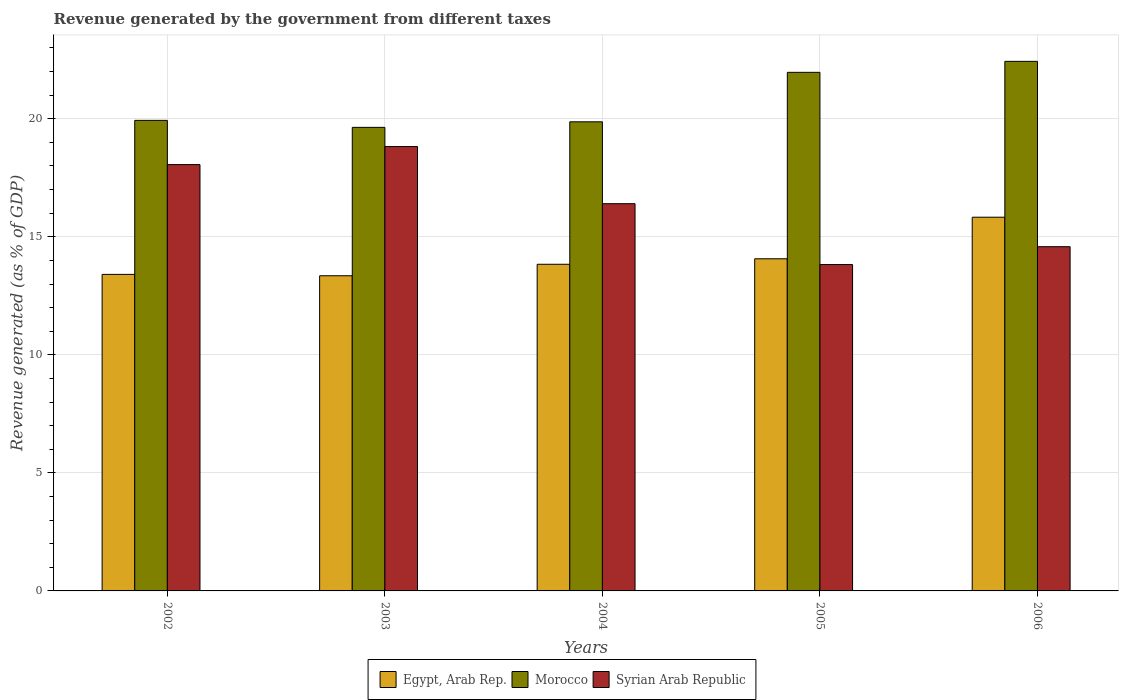How many different coloured bars are there?
Offer a very short reply. 3. How many bars are there on the 1st tick from the left?
Your answer should be very brief. 3. What is the label of the 2nd group of bars from the left?
Offer a terse response. 2003. In how many cases, is the number of bars for a given year not equal to the number of legend labels?
Your response must be concise. 0. What is the revenue generated by the government in Morocco in 2003?
Your answer should be compact. 19.64. Across all years, what is the maximum revenue generated by the government in Egypt, Arab Rep.?
Offer a terse response. 15.83. Across all years, what is the minimum revenue generated by the government in Egypt, Arab Rep.?
Keep it short and to the point. 13.35. In which year was the revenue generated by the government in Egypt, Arab Rep. maximum?
Your response must be concise. 2006. What is the total revenue generated by the government in Egypt, Arab Rep. in the graph?
Provide a short and direct response. 70.49. What is the difference between the revenue generated by the government in Egypt, Arab Rep. in 2005 and that in 2006?
Your answer should be very brief. -1.76. What is the difference between the revenue generated by the government in Morocco in 2005 and the revenue generated by the government in Syrian Arab Republic in 2004?
Provide a short and direct response. 5.56. What is the average revenue generated by the government in Egypt, Arab Rep. per year?
Offer a very short reply. 14.1. In the year 2002, what is the difference between the revenue generated by the government in Egypt, Arab Rep. and revenue generated by the government in Morocco?
Your answer should be compact. -6.52. What is the ratio of the revenue generated by the government in Egypt, Arab Rep. in 2002 to that in 2004?
Your response must be concise. 0.97. Is the revenue generated by the government in Morocco in 2004 less than that in 2005?
Your answer should be compact. Yes. Is the difference between the revenue generated by the government in Egypt, Arab Rep. in 2004 and 2005 greater than the difference between the revenue generated by the government in Morocco in 2004 and 2005?
Make the answer very short. Yes. What is the difference between the highest and the second highest revenue generated by the government in Morocco?
Keep it short and to the point. 0.47. What is the difference between the highest and the lowest revenue generated by the government in Egypt, Arab Rep.?
Ensure brevity in your answer.  2.48. In how many years, is the revenue generated by the government in Morocco greater than the average revenue generated by the government in Morocco taken over all years?
Offer a terse response. 2. What does the 1st bar from the left in 2003 represents?
Provide a short and direct response. Egypt, Arab Rep. What does the 1st bar from the right in 2005 represents?
Offer a terse response. Syrian Arab Republic. Is it the case that in every year, the sum of the revenue generated by the government in Morocco and revenue generated by the government in Egypt, Arab Rep. is greater than the revenue generated by the government in Syrian Arab Republic?
Offer a very short reply. Yes. How many bars are there?
Offer a terse response. 15. Are all the bars in the graph horizontal?
Your answer should be compact. No. Are the values on the major ticks of Y-axis written in scientific E-notation?
Make the answer very short. No. Does the graph contain grids?
Offer a very short reply. Yes. Where does the legend appear in the graph?
Your response must be concise. Bottom center. What is the title of the graph?
Your answer should be very brief. Revenue generated by the government from different taxes. What is the label or title of the Y-axis?
Ensure brevity in your answer.  Revenue generated (as % of GDP). What is the Revenue generated (as % of GDP) in Egypt, Arab Rep. in 2002?
Make the answer very short. 13.41. What is the Revenue generated (as % of GDP) of Morocco in 2002?
Offer a terse response. 19.93. What is the Revenue generated (as % of GDP) in Syrian Arab Republic in 2002?
Keep it short and to the point. 18.06. What is the Revenue generated (as % of GDP) of Egypt, Arab Rep. in 2003?
Provide a short and direct response. 13.35. What is the Revenue generated (as % of GDP) in Morocco in 2003?
Your answer should be very brief. 19.64. What is the Revenue generated (as % of GDP) in Syrian Arab Republic in 2003?
Ensure brevity in your answer.  18.82. What is the Revenue generated (as % of GDP) of Egypt, Arab Rep. in 2004?
Keep it short and to the point. 13.84. What is the Revenue generated (as % of GDP) in Morocco in 2004?
Keep it short and to the point. 19.87. What is the Revenue generated (as % of GDP) in Syrian Arab Republic in 2004?
Give a very brief answer. 16.4. What is the Revenue generated (as % of GDP) of Egypt, Arab Rep. in 2005?
Your answer should be very brief. 14.07. What is the Revenue generated (as % of GDP) in Morocco in 2005?
Your answer should be very brief. 21.97. What is the Revenue generated (as % of GDP) of Syrian Arab Republic in 2005?
Offer a very short reply. 13.82. What is the Revenue generated (as % of GDP) of Egypt, Arab Rep. in 2006?
Provide a short and direct response. 15.83. What is the Revenue generated (as % of GDP) of Morocco in 2006?
Your answer should be very brief. 22.43. What is the Revenue generated (as % of GDP) in Syrian Arab Republic in 2006?
Provide a succinct answer. 14.58. Across all years, what is the maximum Revenue generated (as % of GDP) of Egypt, Arab Rep.?
Your answer should be very brief. 15.83. Across all years, what is the maximum Revenue generated (as % of GDP) of Morocco?
Give a very brief answer. 22.43. Across all years, what is the maximum Revenue generated (as % of GDP) in Syrian Arab Republic?
Provide a succinct answer. 18.82. Across all years, what is the minimum Revenue generated (as % of GDP) of Egypt, Arab Rep.?
Your response must be concise. 13.35. Across all years, what is the minimum Revenue generated (as % of GDP) of Morocco?
Offer a very short reply. 19.64. Across all years, what is the minimum Revenue generated (as % of GDP) of Syrian Arab Republic?
Your answer should be compact. 13.82. What is the total Revenue generated (as % of GDP) of Egypt, Arab Rep. in the graph?
Your answer should be very brief. 70.49. What is the total Revenue generated (as % of GDP) in Morocco in the graph?
Make the answer very short. 103.84. What is the total Revenue generated (as % of GDP) in Syrian Arab Republic in the graph?
Keep it short and to the point. 81.69. What is the difference between the Revenue generated (as % of GDP) of Egypt, Arab Rep. in 2002 and that in 2003?
Your response must be concise. 0.06. What is the difference between the Revenue generated (as % of GDP) in Morocco in 2002 and that in 2003?
Make the answer very short. 0.3. What is the difference between the Revenue generated (as % of GDP) in Syrian Arab Republic in 2002 and that in 2003?
Your response must be concise. -0.76. What is the difference between the Revenue generated (as % of GDP) in Egypt, Arab Rep. in 2002 and that in 2004?
Offer a terse response. -0.43. What is the difference between the Revenue generated (as % of GDP) in Morocco in 2002 and that in 2004?
Provide a succinct answer. 0.06. What is the difference between the Revenue generated (as % of GDP) in Syrian Arab Republic in 2002 and that in 2004?
Offer a very short reply. 1.66. What is the difference between the Revenue generated (as % of GDP) of Egypt, Arab Rep. in 2002 and that in 2005?
Ensure brevity in your answer.  -0.66. What is the difference between the Revenue generated (as % of GDP) of Morocco in 2002 and that in 2005?
Keep it short and to the point. -2.03. What is the difference between the Revenue generated (as % of GDP) of Syrian Arab Republic in 2002 and that in 2005?
Offer a very short reply. 4.23. What is the difference between the Revenue generated (as % of GDP) in Egypt, Arab Rep. in 2002 and that in 2006?
Ensure brevity in your answer.  -2.42. What is the difference between the Revenue generated (as % of GDP) of Morocco in 2002 and that in 2006?
Ensure brevity in your answer.  -2.5. What is the difference between the Revenue generated (as % of GDP) in Syrian Arab Republic in 2002 and that in 2006?
Your answer should be very brief. 3.48. What is the difference between the Revenue generated (as % of GDP) in Egypt, Arab Rep. in 2003 and that in 2004?
Make the answer very short. -0.49. What is the difference between the Revenue generated (as % of GDP) of Morocco in 2003 and that in 2004?
Your answer should be very brief. -0.24. What is the difference between the Revenue generated (as % of GDP) in Syrian Arab Republic in 2003 and that in 2004?
Offer a terse response. 2.42. What is the difference between the Revenue generated (as % of GDP) in Egypt, Arab Rep. in 2003 and that in 2005?
Offer a terse response. -0.72. What is the difference between the Revenue generated (as % of GDP) in Morocco in 2003 and that in 2005?
Ensure brevity in your answer.  -2.33. What is the difference between the Revenue generated (as % of GDP) of Syrian Arab Republic in 2003 and that in 2005?
Your answer should be very brief. 5. What is the difference between the Revenue generated (as % of GDP) of Egypt, Arab Rep. in 2003 and that in 2006?
Your answer should be compact. -2.48. What is the difference between the Revenue generated (as % of GDP) of Morocco in 2003 and that in 2006?
Your response must be concise. -2.8. What is the difference between the Revenue generated (as % of GDP) in Syrian Arab Republic in 2003 and that in 2006?
Make the answer very short. 4.24. What is the difference between the Revenue generated (as % of GDP) of Egypt, Arab Rep. in 2004 and that in 2005?
Your answer should be compact. -0.23. What is the difference between the Revenue generated (as % of GDP) in Morocco in 2004 and that in 2005?
Provide a succinct answer. -2.09. What is the difference between the Revenue generated (as % of GDP) of Syrian Arab Republic in 2004 and that in 2005?
Offer a terse response. 2.58. What is the difference between the Revenue generated (as % of GDP) of Egypt, Arab Rep. in 2004 and that in 2006?
Give a very brief answer. -1.99. What is the difference between the Revenue generated (as % of GDP) of Morocco in 2004 and that in 2006?
Offer a terse response. -2.56. What is the difference between the Revenue generated (as % of GDP) in Syrian Arab Republic in 2004 and that in 2006?
Give a very brief answer. 1.82. What is the difference between the Revenue generated (as % of GDP) in Egypt, Arab Rep. in 2005 and that in 2006?
Your answer should be compact. -1.76. What is the difference between the Revenue generated (as % of GDP) of Morocco in 2005 and that in 2006?
Make the answer very short. -0.47. What is the difference between the Revenue generated (as % of GDP) of Syrian Arab Republic in 2005 and that in 2006?
Provide a succinct answer. -0.76. What is the difference between the Revenue generated (as % of GDP) in Egypt, Arab Rep. in 2002 and the Revenue generated (as % of GDP) in Morocco in 2003?
Offer a terse response. -6.23. What is the difference between the Revenue generated (as % of GDP) of Egypt, Arab Rep. in 2002 and the Revenue generated (as % of GDP) of Syrian Arab Republic in 2003?
Give a very brief answer. -5.42. What is the difference between the Revenue generated (as % of GDP) of Morocco in 2002 and the Revenue generated (as % of GDP) of Syrian Arab Republic in 2003?
Provide a succinct answer. 1.11. What is the difference between the Revenue generated (as % of GDP) in Egypt, Arab Rep. in 2002 and the Revenue generated (as % of GDP) in Morocco in 2004?
Provide a succinct answer. -6.46. What is the difference between the Revenue generated (as % of GDP) in Egypt, Arab Rep. in 2002 and the Revenue generated (as % of GDP) in Syrian Arab Republic in 2004?
Your answer should be compact. -2.99. What is the difference between the Revenue generated (as % of GDP) in Morocco in 2002 and the Revenue generated (as % of GDP) in Syrian Arab Republic in 2004?
Your response must be concise. 3.53. What is the difference between the Revenue generated (as % of GDP) in Egypt, Arab Rep. in 2002 and the Revenue generated (as % of GDP) in Morocco in 2005?
Offer a terse response. -8.56. What is the difference between the Revenue generated (as % of GDP) in Egypt, Arab Rep. in 2002 and the Revenue generated (as % of GDP) in Syrian Arab Republic in 2005?
Your response must be concise. -0.42. What is the difference between the Revenue generated (as % of GDP) of Morocco in 2002 and the Revenue generated (as % of GDP) of Syrian Arab Republic in 2005?
Give a very brief answer. 6.11. What is the difference between the Revenue generated (as % of GDP) of Egypt, Arab Rep. in 2002 and the Revenue generated (as % of GDP) of Morocco in 2006?
Keep it short and to the point. -9.02. What is the difference between the Revenue generated (as % of GDP) in Egypt, Arab Rep. in 2002 and the Revenue generated (as % of GDP) in Syrian Arab Republic in 2006?
Your answer should be very brief. -1.17. What is the difference between the Revenue generated (as % of GDP) in Morocco in 2002 and the Revenue generated (as % of GDP) in Syrian Arab Republic in 2006?
Give a very brief answer. 5.35. What is the difference between the Revenue generated (as % of GDP) in Egypt, Arab Rep. in 2003 and the Revenue generated (as % of GDP) in Morocco in 2004?
Offer a very short reply. -6.52. What is the difference between the Revenue generated (as % of GDP) of Egypt, Arab Rep. in 2003 and the Revenue generated (as % of GDP) of Syrian Arab Republic in 2004?
Provide a succinct answer. -3.05. What is the difference between the Revenue generated (as % of GDP) of Morocco in 2003 and the Revenue generated (as % of GDP) of Syrian Arab Republic in 2004?
Make the answer very short. 3.23. What is the difference between the Revenue generated (as % of GDP) in Egypt, Arab Rep. in 2003 and the Revenue generated (as % of GDP) in Morocco in 2005?
Provide a succinct answer. -8.62. What is the difference between the Revenue generated (as % of GDP) in Egypt, Arab Rep. in 2003 and the Revenue generated (as % of GDP) in Syrian Arab Republic in 2005?
Give a very brief answer. -0.47. What is the difference between the Revenue generated (as % of GDP) in Morocco in 2003 and the Revenue generated (as % of GDP) in Syrian Arab Republic in 2005?
Ensure brevity in your answer.  5.81. What is the difference between the Revenue generated (as % of GDP) in Egypt, Arab Rep. in 2003 and the Revenue generated (as % of GDP) in Morocco in 2006?
Offer a terse response. -9.08. What is the difference between the Revenue generated (as % of GDP) in Egypt, Arab Rep. in 2003 and the Revenue generated (as % of GDP) in Syrian Arab Republic in 2006?
Provide a short and direct response. -1.23. What is the difference between the Revenue generated (as % of GDP) of Morocco in 2003 and the Revenue generated (as % of GDP) of Syrian Arab Republic in 2006?
Your response must be concise. 5.05. What is the difference between the Revenue generated (as % of GDP) in Egypt, Arab Rep. in 2004 and the Revenue generated (as % of GDP) in Morocco in 2005?
Provide a short and direct response. -8.13. What is the difference between the Revenue generated (as % of GDP) of Egypt, Arab Rep. in 2004 and the Revenue generated (as % of GDP) of Syrian Arab Republic in 2005?
Provide a succinct answer. 0.01. What is the difference between the Revenue generated (as % of GDP) of Morocco in 2004 and the Revenue generated (as % of GDP) of Syrian Arab Republic in 2005?
Keep it short and to the point. 6.05. What is the difference between the Revenue generated (as % of GDP) in Egypt, Arab Rep. in 2004 and the Revenue generated (as % of GDP) in Morocco in 2006?
Offer a terse response. -8.6. What is the difference between the Revenue generated (as % of GDP) in Egypt, Arab Rep. in 2004 and the Revenue generated (as % of GDP) in Syrian Arab Republic in 2006?
Give a very brief answer. -0.74. What is the difference between the Revenue generated (as % of GDP) of Morocco in 2004 and the Revenue generated (as % of GDP) of Syrian Arab Republic in 2006?
Keep it short and to the point. 5.29. What is the difference between the Revenue generated (as % of GDP) of Egypt, Arab Rep. in 2005 and the Revenue generated (as % of GDP) of Morocco in 2006?
Provide a succinct answer. -8.36. What is the difference between the Revenue generated (as % of GDP) in Egypt, Arab Rep. in 2005 and the Revenue generated (as % of GDP) in Syrian Arab Republic in 2006?
Ensure brevity in your answer.  -0.51. What is the difference between the Revenue generated (as % of GDP) in Morocco in 2005 and the Revenue generated (as % of GDP) in Syrian Arab Republic in 2006?
Provide a short and direct response. 7.39. What is the average Revenue generated (as % of GDP) in Egypt, Arab Rep. per year?
Your answer should be compact. 14.1. What is the average Revenue generated (as % of GDP) of Morocco per year?
Offer a terse response. 20.77. What is the average Revenue generated (as % of GDP) in Syrian Arab Republic per year?
Offer a very short reply. 16.34. In the year 2002, what is the difference between the Revenue generated (as % of GDP) in Egypt, Arab Rep. and Revenue generated (as % of GDP) in Morocco?
Provide a short and direct response. -6.52. In the year 2002, what is the difference between the Revenue generated (as % of GDP) of Egypt, Arab Rep. and Revenue generated (as % of GDP) of Syrian Arab Republic?
Provide a short and direct response. -4.65. In the year 2002, what is the difference between the Revenue generated (as % of GDP) of Morocco and Revenue generated (as % of GDP) of Syrian Arab Republic?
Provide a short and direct response. 1.87. In the year 2003, what is the difference between the Revenue generated (as % of GDP) of Egypt, Arab Rep. and Revenue generated (as % of GDP) of Morocco?
Your response must be concise. -6.29. In the year 2003, what is the difference between the Revenue generated (as % of GDP) of Egypt, Arab Rep. and Revenue generated (as % of GDP) of Syrian Arab Republic?
Provide a succinct answer. -5.47. In the year 2003, what is the difference between the Revenue generated (as % of GDP) of Morocco and Revenue generated (as % of GDP) of Syrian Arab Republic?
Ensure brevity in your answer.  0.81. In the year 2004, what is the difference between the Revenue generated (as % of GDP) of Egypt, Arab Rep. and Revenue generated (as % of GDP) of Morocco?
Ensure brevity in your answer.  -6.04. In the year 2004, what is the difference between the Revenue generated (as % of GDP) of Egypt, Arab Rep. and Revenue generated (as % of GDP) of Syrian Arab Republic?
Your answer should be very brief. -2.57. In the year 2004, what is the difference between the Revenue generated (as % of GDP) of Morocco and Revenue generated (as % of GDP) of Syrian Arab Republic?
Make the answer very short. 3.47. In the year 2005, what is the difference between the Revenue generated (as % of GDP) of Egypt, Arab Rep. and Revenue generated (as % of GDP) of Morocco?
Your answer should be very brief. -7.9. In the year 2005, what is the difference between the Revenue generated (as % of GDP) in Egypt, Arab Rep. and Revenue generated (as % of GDP) in Syrian Arab Republic?
Offer a very short reply. 0.24. In the year 2005, what is the difference between the Revenue generated (as % of GDP) in Morocco and Revenue generated (as % of GDP) in Syrian Arab Republic?
Provide a short and direct response. 8.14. In the year 2006, what is the difference between the Revenue generated (as % of GDP) in Egypt, Arab Rep. and Revenue generated (as % of GDP) in Morocco?
Give a very brief answer. -6.6. In the year 2006, what is the difference between the Revenue generated (as % of GDP) of Egypt, Arab Rep. and Revenue generated (as % of GDP) of Syrian Arab Republic?
Ensure brevity in your answer.  1.25. In the year 2006, what is the difference between the Revenue generated (as % of GDP) in Morocco and Revenue generated (as % of GDP) in Syrian Arab Republic?
Provide a succinct answer. 7.85. What is the ratio of the Revenue generated (as % of GDP) in Egypt, Arab Rep. in 2002 to that in 2003?
Offer a very short reply. 1. What is the ratio of the Revenue generated (as % of GDP) of Morocco in 2002 to that in 2003?
Keep it short and to the point. 1.02. What is the ratio of the Revenue generated (as % of GDP) in Syrian Arab Republic in 2002 to that in 2003?
Offer a very short reply. 0.96. What is the ratio of the Revenue generated (as % of GDP) of Egypt, Arab Rep. in 2002 to that in 2004?
Your answer should be compact. 0.97. What is the ratio of the Revenue generated (as % of GDP) in Syrian Arab Republic in 2002 to that in 2004?
Provide a succinct answer. 1.1. What is the ratio of the Revenue generated (as % of GDP) in Egypt, Arab Rep. in 2002 to that in 2005?
Ensure brevity in your answer.  0.95. What is the ratio of the Revenue generated (as % of GDP) in Morocco in 2002 to that in 2005?
Offer a terse response. 0.91. What is the ratio of the Revenue generated (as % of GDP) in Syrian Arab Republic in 2002 to that in 2005?
Make the answer very short. 1.31. What is the ratio of the Revenue generated (as % of GDP) in Egypt, Arab Rep. in 2002 to that in 2006?
Your response must be concise. 0.85. What is the ratio of the Revenue generated (as % of GDP) in Morocco in 2002 to that in 2006?
Provide a succinct answer. 0.89. What is the ratio of the Revenue generated (as % of GDP) of Syrian Arab Republic in 2002 to that in 2006?
Give a very brief answer. 1.24. What is the ratio of the Revenue generated (as % of GDP) of Egypt, Arab Rep. in 2003 to that in 2004?
Keep it short and to the point. 0.96. What is the ratio of the Revenue generated (as % of GDP) in Syrian Arab Republic in 2003 to that in 2004?
Make the answer very short. 1.15. What is the ratio of the Revenue generated (as % of GDP) of Egypt, Arab Rep. in 2003 to that in 2005?
Your answer should be very brief. 0.95. What is the ratio of the Revenue generated (as % of GDP) in Morocco in 2003 to that in 2005?
Ensure brevity in your answer.  0.89. What is the ratio of the Revenue generated (as % of GDP) in Syrian Arab Republic in 2003 to that in 2005?
Ensure brevity in your answer.  1.36. What is the ratio of the Revenue generated (as % of GDP) in Egypt, Arab Rep. in 2003 to that in 2006?
Give a very brief answer. 0.84. What is the ratio of the Revenue generated (as % of GDP) of Morocco in 2003 to that in 2006?
Offer a very short reply. 0.88. What is the ratio of the Revenue generated (as % of GDP) in Syrian Arab Republic in 2003 to that in 2006?
Provide a succinct answer. 1.29. What is the ratio of the Revenue generated (as % of GDP) of Egypt, Arab Rep. in 2004 to that in 2005?
Offer a very short reply. 0.98. What is the ratio of the Revenue generated (as % of GDP) in Morocco in 2004 to that in 2005?
Give a very brief answer. 0.9. What is the ratio of the Revenue generated (as % of GDP) of Syrian Arab Republic in 2004 to that in 2005?
Your answer should be very brief. 1.19. What is the ratio of the Revenue generated (as % of GDP) of Egypt, Arab Rep. in 2004 to that in 2006?
Ensure brevity in your answer.  0.87. What is the ratio of the Revenue generated (as % of GDP) of Morocco in 2004 to that in 2006?
Provide a succinct answer. 0.89. What is the ratio of the Revenue generated (as % of GDP) of Syrian Arab Republic in 2004 to that in 2006?
Provide a succinct answer. 1.12. What is the ratio of the Revenue generated (as % of GDP) in Egypt, Arab Rep. in 2005 to that in 2006?
Give a very brief answer. 0.89. What is the ratio of the Revenue generated (as % of GDP) of Morocco in 2005 to that in 2006?
Offer a terse response. 0.98. What is the ratio of the Revenue generated (as % of GDP) of Syrian Arab Republic in 2005 to that in 2006?
Ensure brevity in your answer.  0.95. What is the difference between the highest and the second highest Revenue generated (as % of GDP) of Egypt, Arab Rep.?
Keep it short and to the point. 1.76. What is the difference between the highest and the second highest Revenue generated (as % of GDP) in Morocco?
Provide a short and direct response. 0.47. What is the difference between the highest and the second highest Revenue generated (as % of GDP) in Syrian Arab Republic?
Your answer should be very brief. 0.76. What is the difference between the highest and the lowest Revenue generated (as % of GDP) of Egypt, Arab Rep.?
Provide a succinct answer. 2.48. What is the difference between the highest and the lowest Revenue generated (as % of GDP) in Morocco?
Offer a terse response. 2.8. What is the difference between the highest and the lowest Revenue generated (as % of GDP) of Syrian Arab Republic?
Offer a terse response. 5. 